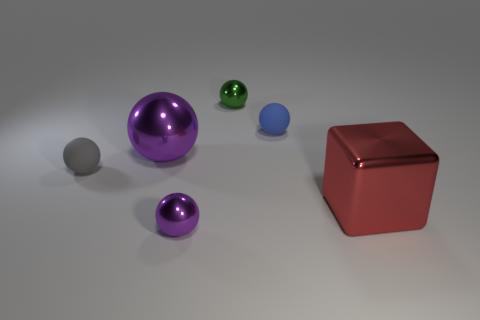How many objects in the image could roll if placed on a slope? There are four spherical objects in the image that could roll if placed on a slope: one large purple sphere, one smaller green sphere, and two smaller spheres, one blue and one grey. Which object in the image is the largest? The largest object in the image is the purple sphere, which has a significant size in comparison to the other items. 